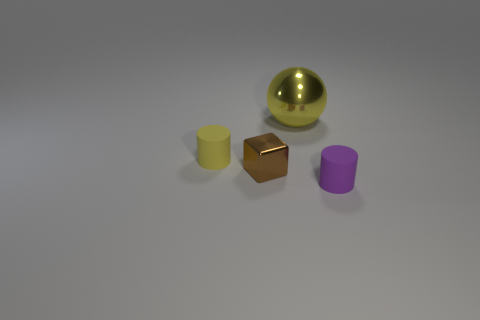Subtract all balls. How many objects are left? 3 Add 2 small brown things. How many objects exist? 6 Subtract all yellow spheres. Subtract all purple cylinders. How many objects are left? 2 Add 4 tiny cylinders. How many tiny cylinders are left? 6 Add 1 rubber cubes. How many rubber cubes exist? 1 Subtract 0 purple cubes. How many objects are left? 4 